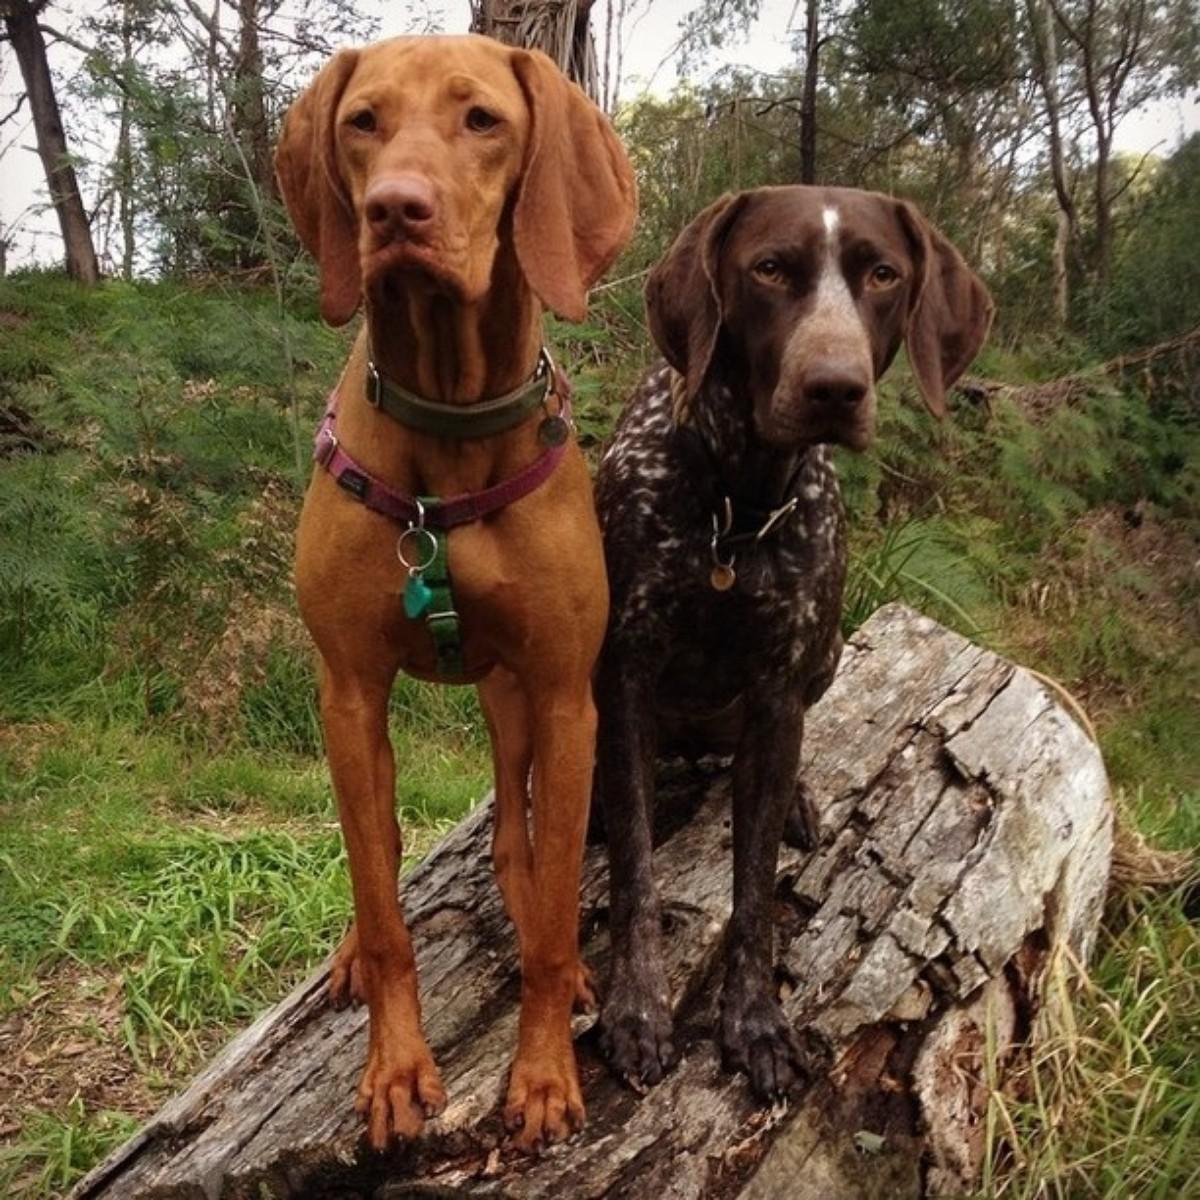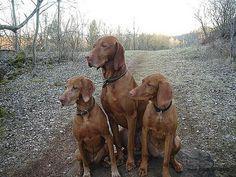The first image is the image on the left, the second image is the image on the right. Considering the images on both sides, is "In at least one image there are two hunting dogs with collars on." valid? Answer yes or no. Yes. The first image is the image on the left, the second image is the image on the right. For the images displayed, is the sentence "In the right image, red-orange dogs are on each side of a man with a strap on his front." factually correct? Answer yes or no. No. 